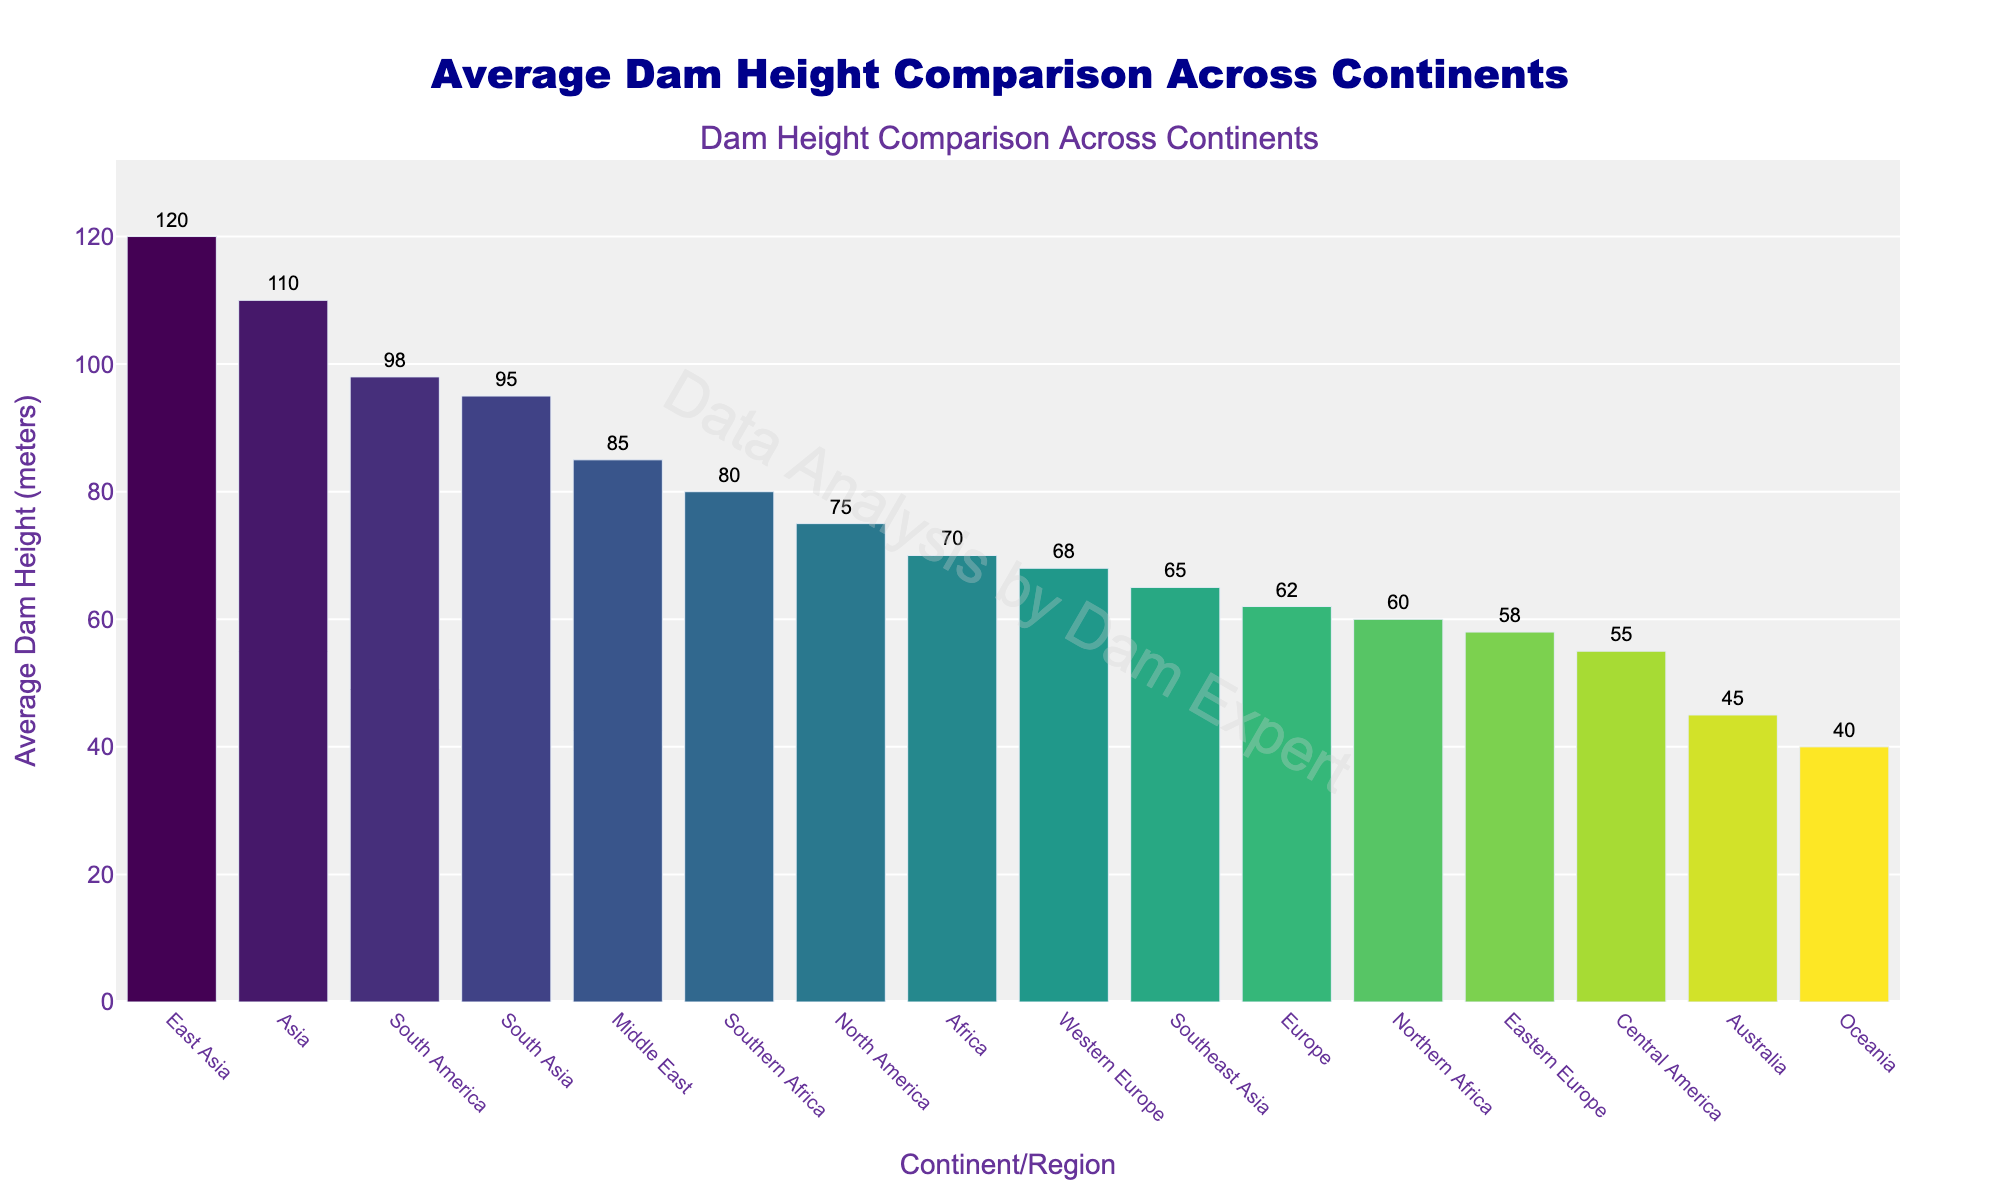Which continent has the highest average dam height? The bar representing East Asia is the tallest in the chart, indicating that East Asia has the highest average dam height.
Answer: East Asia What is the difference in average dam height between East Asia and Australia? The average dam height for East Asia is 120 meters, and for Australia, it is 45 meters. The difference is 120 - 45.
Answer: 75 meters Which continents have a lower average dam height than Europe? The average dam height for Europe (Western Europe) is 68 meters. The continents lower than this are Australia (45 meters), Central America (55 meters), Eastern Europe (58 meters), and Northern Africa (60 meters).
Answer: Australia, Central America, Eastern Europe, Northern Africa What is the average dam height of Africa and how does it compare to South America? Africa (Northern and Southern Africa combined) has average heights of 60 meters and 80 meters respectively. South America has an average dam height of 98 meters. Therefore, comparing the highest (Southern Africa) and South America: 80 is less than 98 meters.
Answer: Less than South America How many continents have an average dam height greater than 70 meters? The continents with average heights greater than 70 meters are South America (98), Asia (110), Middle East (85), South Asia (95), East Asia (120), and Southern Africa (80). There are 6 such continents.
Answer: 6 continents 